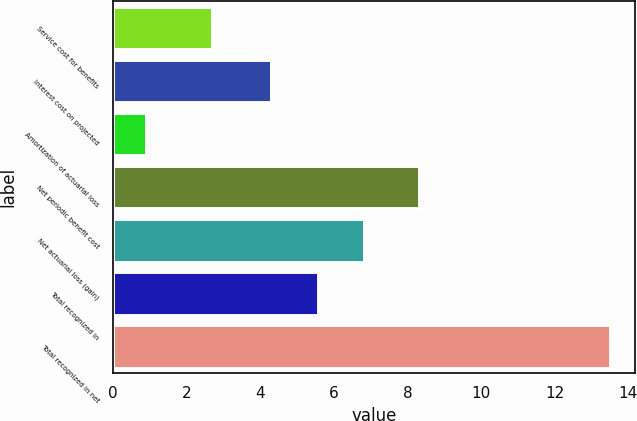<chart> <loc_0><loc_0><loc_500><loc_500><bar_chart><fcel>Service cost for benefits<fcel>Interest cost on projected<fcel>Amortization of actuarial loss<fcel>Net periodic benefit cost<fcel>Net actuarial loss (gain)<fcel>Total recognized in<fcel>Total recognized in net<nl><fcel>2.7<fcel>4.3<fcel>0.9<fcel>8.3<fcel>6.82<fcel>5.56<fcel>13.5<nl></chart> 